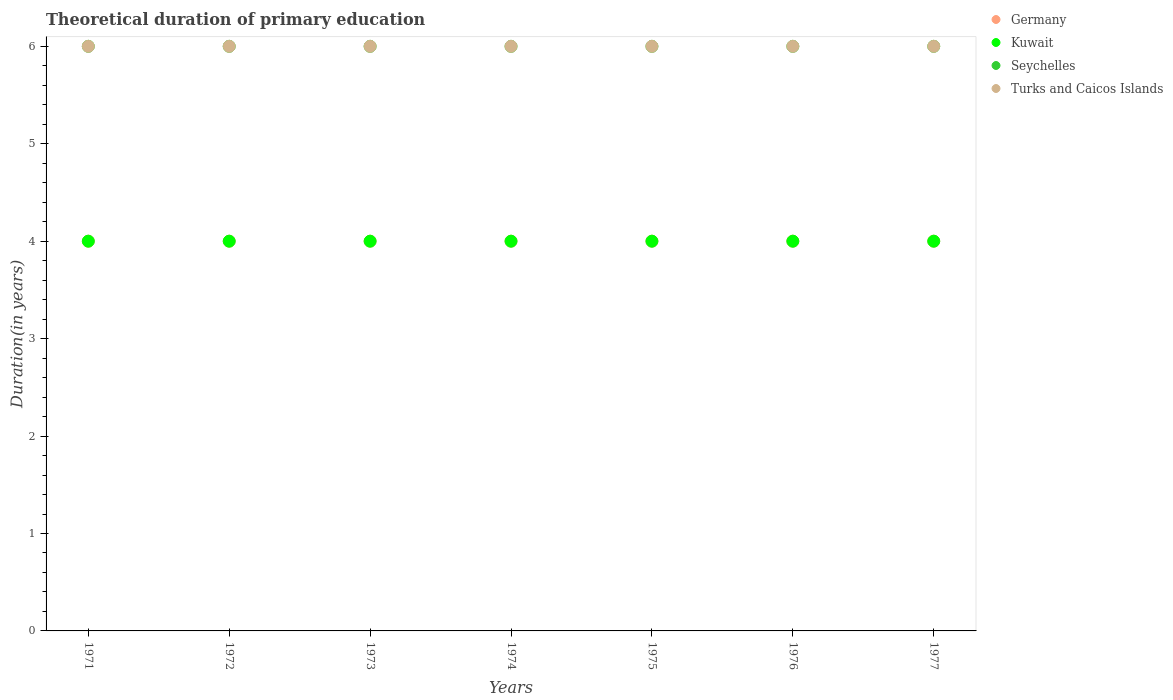Is the number of dotlines equal to the number of legend labels?
Offer a very short reply. Yes. What is the total theoretical duration of primary education in Kuwait in 1974?
Offer a terse response. 4. Across all years, what is the maximum total theoretical duration of primary education in Germany?
Your response must be concise. 4. Across all years, what is the minimum total theoretical duration of primary education in Germany?
Your answer should be compact. 4. In which year was the total theoretical duration of primary education in Seychelles maximum?
Your response must be concise. 1971. What is the total total theoretical duration of primary education in Seychelles in the graph?
Make the answer very short. 42. What is the difference between the total theoretical duration of primary education in Germany in 1973 and the total theoretical duration of primary education in Seychelles in 1976?
Keep it short and to the point. -2. What is the average total theoretical duration of primary education in Seychelles per year?
Provide a succinct answer. 6. In the year 1972, what is the difference between the total theoretical duration of primary education in Turks and Caicos Islands and total theoretical duration of primary education in Germany?
Give a very brief answer. 2. Is the difference between the total theoretical duration of primary education in Turks and Caicos Islands in 1974 and 1976 greater than the difference between the total theoretical duration of primary education in Germany in 1974 and 1976?
Offer a terse response. No. What is the difference between the highest and the lowest total theoretical duration of primary education in Turks and Caicos Islands?
Ensure brevity in your answer.  0. Is it the case that in every year, the sum of the total theoretical duration of primary education in Turks and Caicos Islands and total theoretical duration of primary education in Seychelles  is greater than the sum of total theoretical duration of primary education in Germany and total theoretical duration of primary education in Kuwait?
Offer a very short reply. Yes. How many years are there in the graph?
Provide a succinct answer. 7. Are the values on the major ticks of Y-axis written in scientific E-notation?
Provide a succinct answer. No. Does the graph contain any zero values?
Keep it short and to the point. No. Where does the legend appear in the graph?
Make the answer very short. Top right. How many legend labels are there?
Ensure brevity in your answer.  4. How are the legend labels stacked?
Your response must be concise. Vertical. What is the title of the graph?
Make the answer very short. Theoretical duration of primary education. What is the label or title of the X-axis?
Make the answer very short. Years. What is the label or title of the Y-axis?
Your answer should be compact. Duration(in years). What is the Duration(in years) in Kuwait in 1971?
Your answer should be very brief. 4. What is the Duration(in years) of Seychelles in 1971?
Make the answer very short. 6. What is the Duration(in years) of Germany in 1972?
Provide a succinct answer. 4. What is the Duration(in years) in Kuwait in 1972?
Your response must be concise. 4. What is the Duration(in years) in Turks and Caicos Islands in 1973?
Ensure brevity in your answer.  6. What is the Duration(in years) of Turks and Caicos Islands in 1974?
Provide a short and direct response. 6. What is the Duration(in years) of Seychelles in 1975?
Ensure brevity in your answer.  6. What is the Duration(in years) of Kuwait in 1976?
Your answer should be very brief. 4. What is the Duration(in years) of Turks and Caicos Islands in 1976?
Your response must be concise. 6. What is the Duration(in years) of Kuwait in 1977?
Ensure brevity in your answer.  4. What is the Duration(in years) in Seychelles in 1977?
Provide a succinct answer. 6. Across all years, what is the maximum Duration(in years) in Germany?
Offer a very short reply. 4. Across all years, what is the maximum Duration(in years) of Kuwait?
Your response must be concise. 4. Across all years, what is the minimum Duration(in years) in Germany?
Your response must be concise. 4. Across all years, what is the minimum Duration(in years) in Kuwait?
Offer a terse response. 4. Across all years, what is the minimum Duration(in years) of Turks and Caicos Islands?
Ensure brevity in your answer.  6. What is the total Duration(in years) in Kuwait in the graph?
Offer a terse response. 28. What is the total Duration(in years) of Seychelles in the graph?
Offer a terse response. 42. What is the difference between the Duration(in years) in Germany in 1971 and that in 1972?
Keep it short and to the point. 0. What is the difference between the Duration(in years) of Kuwait in 1971 and that in 1972?
Keep it short and to the point. 0. What is the difference between the Duration(in years) of Seychelles in 1971 and that in 1972?
Provide a short and direct response. 0. What is the difference between the Duration(in years) of Turks and Caicos Islands in 1971 and that in 1972?
Your response must be concise. 0. What is the difference between the Duration(in years) of Kuwait in 1971 and that in 1973?
Offer a very short reply. 0. What is the difference between the Duration(in years) of Seychelles in 1971 and that in 1973?
Ensure brevity in your answer.  0. What is the difference between the Duration(in years) of Germany in 1971 and that in 1974?
Keep it short and to the point. 0. What is the difference between the Duration(in years) in Seychelles in 1971 and that in 1974?
Offer a terse response. 0. What is the difference between the Duration(in years) in Turks and Caicos Islands in 1971 and that in 1974?
Keep it short and to the point. 0. What is the difference between the Duration(in years) in Seychelles in 1971 and that in 1975?
Offer a very short reply. 0. What is the difference between the Duration(in years) of Germany in 1971 and that in 1976?
Provide a succinct answer. 0. What is the difference between the Duration(in years) of Seychelles in 1971 and that in 1976?
Offer a terse response. 0. What is the difference between the Duration(in years) in Turks and Caicos Islands in 1971 and that in 1976?
Offer a very short reply. 0. What is the difference between the Duration(in years) in Seychelles in 1971 and that in 1977?
Your answer should be compact. 0. What is the difference between the Duration(in years) in Kuwait in 1972 and that in 1973?
Provide a short and direct response. 0. What is the difference between the Duration(in years) of Turks and Caicos Islands in 1972 and that in 1973?
Keep it short and to the point. 0. What is the difference between the Duration(in years) of Germany in 1972 and that in 1974?
Make the answer very short. 0. What is the difference between the Duration(in years) of Seychelles in 1972 and that in 1974?
Your answer should be very brief. 0. What is the difference between the Duration(in years) of Germany in 1972 and that in 1976?
Provide a short and direct response. 0. What is the difference between the Duration(in years) of Kuwait in 1972 and that in 1977?
Offer a very short reply. 0. What is the difference between the Duration(in years) in Germany in 1973 and that in 1974?
Provide a short and direct response. 0. What is the difference between the Duration(in years) of Kuwait in 1973 and that in 1974?
Offer a terse response. 0. What is the difference between the Duration(in years) in Seychelles in 1973 and that in 1974?
Provide a short and direct response. 0. What is the difference between the Duration(in years) in Turks and Caicos Islands in 1973 and that in 1974?
Offer a terse response. 0. What is the difference between the Duration(in years) of Germany in 1973 and that in 1975?
Keep it short and to the point. 0. What is the difference between the Duration(in years) of Kuwait in 1973 and that in 1975?
Your response must be concise. 0. What is the difference between the Duration(in years) of Seychelles in 1973 and that in 1975?
Provide a succinct answer. 0. What is the difference between the Duration(in years) of Turks and Caicos Islands in 1973 and that in 1975?
Offer a terse response. 0. What is the difference between the Duration(in years) in Germany in 1973 and that in 1977?
Your answer should be very brief. 0. What is the difference between the Duration(in years) in Seychelles in 1973 and that in 1977?
Your answer should be very brief. 0. What is the difference between the Duration(in years) of Turks and Caicos Islands in 1973 and that in 1977?
Your answer should be very brief. 0. What is the difference between the Duration(in years) in Germany in 1974 and that in 1975?
Ensure brevity in your answer.  0. What is the difference between the Duration(in years) of Turks and Caicos Islands in 1974 and that in 1975?
Make the answer very short. 0. What is the difference between the Duration(in years) in Germany in 1974 and that in 1976?
Make the answer very short. 0. What is the difference between the Duration(in years) in Seychelles in 1974 and that in 1976?
Your answer should be very brief. 0. What is the difference between the Duration(in years) of Turks and Caicos Islands in 1974 and that in 1976?
Provide a succinct answer. 0. What is the difference between the Duration(in years) in Kuwait in 1974 and that in 1977?
Your answer should be very brief. 0. What is the difference between the Duration(in years) in Seychelles in 1974 and that in 1977?
Keep it short and to the point. 0. What is the difference between the Duration(in years) in Seychelles in 1975 and that in 1976?
Provide a succinct answer. 0. What is the difference between the Duration(in years) in Turks and Caicos Islands in 1975 and that in 1976?
Make the answer very short. 0. What is the difference between the Duration(in years) in Kuwait in 1976 and that in 1977?
Make the answer very short. 0. What is the difference between the Duration(in years) in Seychelles in 1976 and that in 1977?
Give a very brief answer. 0. What is the difference between the Duration(in years) in Germany in 1971 and the Duration(in years) in Kuwait in 1972?
Offer a terse response. 0. What is the difference between the Duration(in years) of Germany in 1971 and the Duration(in years) of Seychelles in 1972?
Ensure brevity in your answer.  -2. What is the difference between the Duration(in years) in Germany in 1971 and the Duration(in years) in Turks and Caicos Islands in 1972?
Provide a succinct answer. -2. What is the difference between the Duration(in years) in Germany in 1971 and the Duration(in years) in Seychelles in 1973?
Keep it short and to the point. -2. What is the difference between the Duration(in years) of Germany in 1971 and the Duration(in years) of Seychelles in 1974?
Offer a very short reply. -2. What is the difference between the Duration(in years) of Germany in 1971 and the Duration(in years) of Turks and Caicos Islands in 1974?
Ensure brevity in your answer.  -2. What is the difference between the Duration(in years) of Kuwait in 1971 and the Duration(in years) of Seychelles in 1974?
Give a very brief answer. -2. What is the difference between the Duration(in years) of Seychelles in 1971 and the Duration(in years) of Turks and Caicos Islands in 1974?
Your answer should be compact. 0. What is the difference between the Duration(in years) of Germany in 1971 and the Duration(in years) of Kuwait in 1975?
Ensure brevity in your answer.  0. What is the difference between the Duration(in years) in Germany in 1971 and the Duration(in years) in Turks and Caicos Islands in 1975?
Give a very brief answer. -2. What is the difference between the Duration(in years) of Kuwait in 1971 and the Duration(in years) of Turks and Caicos Islands in 1975?
Provide a short and direct response. -2. What is the difference between the Duration(in years) in Seychelles in 1971 and the Duration(in years) in Turks and Caicos Islands in 1975?
Give a very brief answer. 0. What is the difference between the Duration(in years) in Germany in 1971 and the Duration(in years) in Kuwait in 1976?
Provide a succinct answer. 0. What is the difference between the Duration(in years) of Germany in 1971 and the Duration(in years) of Turks and Caicos Islands in 1976?
Make the answer very short. -2. What is the difference between the Duration(in years) of Kuwait in 1971 and the Duration(in years) of Turks and Caicos Islands in 1976?
Offer a very short reply. -2. What is the difference between the Duration(in years) in Germany in 1971 and the Duration(in years) in Kuwait in 1977?
Offer a very short reply. 0. What is the difference between the Duration(in years) in Germany in 1971 and the Duration(in years) in Seychelles in 1977?
Your answer should be very brief. -2. What is the difference between the Duration(in years) in Germany in 1971 and the Duration(in years) in Turks and Caicos Islands in 1977?
Your response must be concise. -2. What is the difference between the Duration(in years) of Kuwait in 1971 and the Duration(in years) of Seychelles in 1977?
Ensure brevity in your answer.  -2. What is the difference between the Duration(in years) in Kuwait in 1971 and the Duration(in years) in Turks and Caicos Islands in 1977?
Your answer should be compact. -2. What is the difference between the Duration(in years) in Seychelles in 1971 and the Duration(in years) in Turks and Caicos Islands in 1977?
Offer a very short reply. 0. What is the difference between the Duration(in years) in Germany in 1972 and the Duration(in years) in Kuwait in 1973?
Your response must be concise. 0. What is the difference between the Duration(in years) in Germany in 1972 and the Duration(in years) in Seychelles in 1973?
Your answer should be compact. -2. What is the difference between the Duration(in years) in Kuwait in 1972 and the Duration(in years) in Seychelles in 1973?
Offer a very short reply. -2. What is the difference between the Duration(in years) of Seychelles in 1972 and the Duration(in years) of Turks and Caicos Islands in 1973?
Your response must be concise. 0. What is the difference between the Duration(in years) in Germany in 1972 and the Duration(in years) in Kuwait in 1974?
Your answer should be very brief. 0. What is the difference between the Duration(in years) in Kuwait in 1972 and the Duration(in years) in Turks and Caicos Islands in 1974?
Your answer should be very brief. -2. What is the difference between the Duration(in years) in Germany in 1972 and the Duration(in years) in Kuwait in 1975?
Offer a terse response. 0. What is the difference between the Duration(in years) in Germany in 1972 and the Duration(in years) in Seychelles in 1975?
Make the answer very short. -2. What is the difference between the Duration(in years) of Germany in 1972 and the Duration(in years) of Turks and Caicos Islands in 1975?
Your answer should be very brief. -2. What is the difference between the Duration(in years) in Kuwait in 1972 and the Duration(in years) in Turks and Caicos Islands in 1975?
Offer a very short reply. -2. What is the difference between the Duration(in years) in Seychelles in 1972 and the Duration(in years) in Turks and Caicos Islands in 1975?
Offer a very short reply. 0. What is the difference between the Duration(in years) in Germany in 1972 and the Duration(in years) in Kuwait in 1976?
Offer a very short reply. 0. What is the difference between the Duration(in years) in Germany in 1973 and the Duration(in years) in Kuwait in 1974?
Keep it short and to the point. 0. What is the difference between the Duration(in years) of Germany in 1973 and the Duration(in years) of Seychelles in 1974?
Provide a short and direct response. -2. What is the difference between the Duration(in years) of Germany in 1973 and the Duration(in years) of Turks and Caicos Islands in 1974?
Provide a short and direct response. -2. What is the difference between the Duration(in years) of Kuwait in 1973 and the Duration(in years) of Seychelles in 1974?
Your answer should be very brief. -2. What is the difference between the Duration(in years) in Germany in 1973 and the Duration(in years) in Seychelles in 1975?
Provide a succinct answer. -2. What is the difference between the Duration(in years) in Kuwait in 1973 and the Duration(in years) in Turks and Caicos Islands in 1975?
Provide a short and direct response. -2. What is the difference between the Duration(in years) in Germany in 1973 and the Duration(in years) in Kuwait in 1976?
Ensure brevity in your answer.  0. What is the difference between the Duration(in years) of Germany in 1973 and the Duration(in years) of Seychelles in 1976?
Keep it short and to the point. -2. What is the difference between the Duration(in years) of Kuwait in 1973 and the Duration(in years) of Turks and Caicos Islands in 1976?
Offer a very short reply. -2. What is the difference between the Duration(in years) in Seychelles in 1973 and the Duration(in years) in Turks and Caicos Islands in 1976?
Make the answer very short. 0. What is the difference between the Duration(in years) of Germany in 1973 and the Duration(in years) of Kuwait in 1977?
Ensure brevity in your answer.  0. What is the difference between the Duration(in years) of Kuwait in 1973 and the Duration(in years) of Turks and Caicos Islands in 1977?
Your response must be concise. -2. What is the difference between the Duration(in years) in Seychelles in 1973 and the Duration(in years) in Turks and Caicos Islands in 1977?
Your response must be concise. 0. What is the difference between the Duration(in years) in Germany in 1974 and the Duration(in years) in Kuwait in 1975?
Keep it short and to the point. 0. What is the difference between the Duration(in years) of Kuwait in 1974 and the Duration(in years) of Seychelles in 1975?
Provide a succinct answer. -2. What is the difference between the Duration(in years) of Kuwait in 1974 and the Duration(in years) of Turks and Caicos Islands in 1975?
Offer a very short reply. -2. What is the difference between the Duration(in years) in Seychelles in 1974 and the Duration(in years) in Turks and Caicos Islands in 1975?
Offer a very short reply. 0. What is the difference between the Duration(in years) of Germany in 1974 and the Duration(in years) of Turks and Caicos Islands in 1976?
Provide a short and direct response. -2. What is the difference between the Duration(in years) of Kuwait in 1974 and the Duration(in years) of Turks and Caicos Islands in 1976?
Give a very brief answer. -2. What is the difference between the Duration(in years) in Germany in 1974 and the Duration(in years) in Kuwait in 1977?
Your answer should be compact. 0. What is the difference between the Duration(in years) of Kuwait in 1974 and the Duration(in years) of Seychelles in 1977?
Your answer should be compact. -2. What is the difference between the Duration(in years) of Germany in 1975 and the Duration(in years) of Turks and Caicos Islands in 1976?
Your answer should be very brief. -2. What is the difference between the Duration(in years) of Kuwait in 1975 and the Duration(in years) of Seychelles in 1976?
Your answer should be very brief. -2. What is the difference between the Duration(in years) in Kuwait in 1975 and the Duration(in years) in Turks and Caicos Islands in 1976?
Offer a terse response. -2. What is the difference between the Duration(in years) of Germany in 1975 and the Duration(in years) of Kuwait in 1977?
Your answer should be compact. 0. What is the difference between the Duration(in years) in Germany in 1975 and the Duration(in years) in Turks and Caicos Islands in 1977?
Offer a very short reply. -2. What is the difference between the Duration(in years) in Germany in 1976 and the Duration(in years) in Kuwait in 1977?
Offer a very short reply. 0. What is the difference between the Duration(in years) in Germany in 1976 and the Duration(in years) in Turks and Caicos Islands in 1977?
Give a very brief answer. -2. What is the difference between the Duration(in years) of Kuwait in 1976 and the Duration(in years) of Seychelles in 1977?
Provide a short and direct response. -2. What is the average Duration(in years) of Kuwait per year?
Your response must be concise. 4. What is the average Duration(in years) in Seychelles per year?
Provide a short and direct response. 6. In the year 1971, what is the difference between the Duration(in years) in Germany and Duration(in years) in Turks and Caicos Islands?
Offer a terse response. -2. In the year 1971, what is the difference between the Duration(in years) in Kuwait and Duration(in years) in Seychelles?
Make the answer very short. -2. In the year 1971, what is the difference between the Duration(in years) of Kuwait and Duration(in years) of Turks and Caicos Islands?
Your answer should be very brief. -2. In the year 1971, what is the difference between the Duration(in years) in Seychelles and Duration(in years) in Turks and Caicos Islands?
Ensure brevity in your answer.  0. In the year 1972, what is the difference between the Duration(in years) of Germany and Duration(in years) of Seychelles?
Your answer should be compact. -2. In the year 1972, what is the difference between the Duration(in years) of Germany and Duration(in years) of Turks and Caicos Islands?
Your answer should be compact. -2. In the year 1972, what is the difference between the Duration(in years) of Kuwait and Duration(in years) of Seychelles?
Your answer should be compact. -2. In the year 1973, what is the difference between the Duration(in years) in Germany and Duration(in years) in Kuwait?
Your answer should be very brief. 0. In the year 1973, what is the difference between the Duration(in years) of Germany and Duration(in years) of Turks and Caicos Islands?
Provide a short and direct response. -2. In the year 1973, what is the difference between the Duration(in years) in Kuwait and Duration(in years) in Turks and Caicos Islands?
Ensure brevity in your answer.  -2. In the year 1973, what is the difference between the Duration(in years) in Seychelles and Duration(in years) in Turks and Caicos Islands?
Offer a terse response. 0. In the year 1974, what is the difference between the Duration(in years) in Germany and Duration(in years) in Kuwait?
Keep it short and to the point. 0. In the year 1974, what is the difference between the Duration(in years) in Germany and Duration(in years) in Seychelles?
Ensure brevity in your answer.  -2. In the year 1974, what is the difference between the Duration(in years) of Kuwait and Duration(in years) of Turks and Caicos Islands?
Ensure brevity in your answer.  -2. In the year 1974, what is the difference between the Duration(in years) in Seychelles and Duration(in years) in Turks and Caicos Islands?
Your answer should be compact. 0. In the year 1975, what is the difference between the Duration(in years) in Germany and Duration(in years) in Seychelles?
Provide a succinct answer. -2. In the year 1976, what is the difference between the Duration(in years) in Germany and Duration(in years) in Turks and Caicos Islands?
Your answer should be very brief. -2. In the year 1976, what is the difference between the Duration(in years) in Kuwait and Duration(in years) in Seychelles?
Keep it short and to the point. -2. In the year 1976, what is the difference between the Duration(in years) in Kuwait and Duration(in years) in Turks and Caicos Islands?
Keep it short and to the point. -2. In the year 1976, what is the difference between the Duration(in years) of Seychelles and Duration(in years) of Turks and Caicos Islands?
Your response must be concise. 0. In the year 1977, what is the difference between the Duration(in years) in Germany and Duration(in years) in Kuwait?
Provide a short and direct response. 0. In the year 1977, what is the difference between the Duration(in years) in Germany and Duration(in years) in Seychelles?
Your answer should be compact. -2. In the year 1977, what is the difference between the Duration(in years) in Germany and Duration(in years) in Turks and Caicos Islands?
Offer a very short reply. -2. In the year 1977, what is the difference between the Duration(in years) of Kuwait and Duration(in years) of Seychelles?
Keep it short and to the point. -2. What is the ratio of the Duration(in years) of Germany in 1971 to that in 1972?
Give a very brief answer. 1. What is the ratio of the Duration(in years) of Seychelles in 1971 to that in 1973?
Make the answer very short. 1. What is the ratio of the Duration(in years) in Germany in 1971 to that in 1974?
Your answer should be very brief. 1. What is the ratio of the Duration(in years) of Seychelles in 1971 to that in 1975?
Provide a short and direct response. 1. What is the ratio of the Duration(in years) in Turks and Caicos Islands in 1971 to that in 1975?
Give a very brief answer. 1. What is the ratio of the Duration(in years) in Germany in 1971 to that in 1976?
Make the answer very short. 1. What is the ratio of the Duration(in years) in Kuwait in 1971 to that in 1976?
Offer a terse response. 1. What is the ratio of the Duration(in years) of Seychelles in 1971 to that in 1976?
Ensure brevity in your answer.  1. What is the ratio of the Duration(in years) in Germany in 1971 to that in 1977?
Keep it short and to the point. 1. What is the ratio of the Duration(in years) of Seychelles in 1971 to that in 1977?
Your answer should be compact. 1. What is the ratio of the Duration(in years) in Germany in 1972 to that in 1973?
Your answer should be very brief. 1. What is the ratio of the Duration(in years) in Germany in 1972 to that in 1974?
Keep it short and to the point. 1. What is the ratio of the Duration(in years) in Turks and Caicos Islands in 1972 to that in 1974?
Keep it short and to the point. 1. What is the ratio of the Duration(in years) of Germany in 1972 to that in 1975?
Offer a terse response. 1. What is the ratio of the Duration(in years) in Kuwait in 1972 to that in 1975?
Your answer should be very brief. 1. What is the ratio of the Duration(in years) in Seychelles in 1972 to that in 1975?
Keep it short and to the point. 1. What is the ratio of the Duration(in years) in Germany in 1972 to that in 1976?
Your answer should be very brief. 1. What is the ratio of the Duration(in years) in Kuwait in 1972 to that in 1976?
Give a very brief answer. 1. What is the ratio of the Duration(in years) of Seychelles in 1972 to that in 1977?
Ensure brevity in your answer.  1. What is the ratio of the Duration(in years) of Germany in 1973 to that in 1974?
Offer a terse response. 1. What is the ratio of the Duration(in years) in Kuwait in 1973 to that in 1974?
Offer a very short reply. 1. What is the ratio of the Duration(in years) in Seychelles in 1973 to that in 1974?
Give a very brief answer. 1. What is the ratio of the Duration(in years) of Kuwait in 1973 to that in 1975?
Make the answer very short. 1. What is the ratio of the Duration(in years) in Seychelles in 1973 to that in 1975?
Provide a short and direct response. 1. What is the ratio of the Duration(in years) in Germany in 1973 to that in 1976?
Your answer should be very brief. 1. What is the ratio of the Duration(in years) of Seychelles in 1973 to that in 1976?
Give a very brief answer. 1. What is the ratio of the Duration(in years) of Turks and Caicos Islands in 1973 to that in 1977?
Your answer should be compact. 1. What is the ratio of the Duration(in years) of Seychelles in 1974 to that in 1975?
Ensure brevity in your answer.  1. What is the ratio of the Duration(in years) in Turks and Caicos Islands in 1974 to that in 1975?
Give a very brief answer. 1. What is the ratio of the Duration(in years) of Kuwait in 1974 to that in 1976?
Provide a short and direct response. 1. What is the ratio of the Duration(in years) in Turks and Caicos Islands in 1974 to that in 1976?
Offer a terse response. 1. What is the ratio of the Duration(in years) of Germany in 1974 to that in 1977?
Offer a very short reply. 1. What is the ratio of the Duration(in years) of Turks and Caicos Islands in 1974 to that in 1977?
Keep it short and to the point. 1. What is the ratio of the Duration(in years) in Seychelles in 1975 to that in 1976?
Your answer should be compact. 1. What is the ratio of the Duration(in years) in Turks and Caicos Islands in 1975 to that in 1976?
Your answer should be compact. 1. What is the ratio of the Duration(in years) of Kuwait in 1975 to that in 1977?
Keep it short and to the point. 1. What is the ratio of the Duration(in years) in Germany in 1976 to that in 1977?
Give a very brief answer. 1. What is the ratio of the Duration(in years) of Kuwait in 1976 to that in 1977?
Offer a very short reply. 1. What is the ratio of the Duration(in years) in Seychelles in 1976 to that in 1977?
Ensure brevity in your answer.  1. What is the ratio of the Duration(in years) in Turks and Caicos Islands in 1976 to that in 1977?
Make the answer very short. 1. What is the difference between the highest and the second highest Duration(in years) in Germany?
Your answer should be compact. 0. What is the difference between the highest and the second highest Duration(in years) in Kuwait?
Your answer should be compact. 0. What is the difference between the highest and the second highest Duration(in years) of Seychelles?
Provide a succinct answer. 0. 